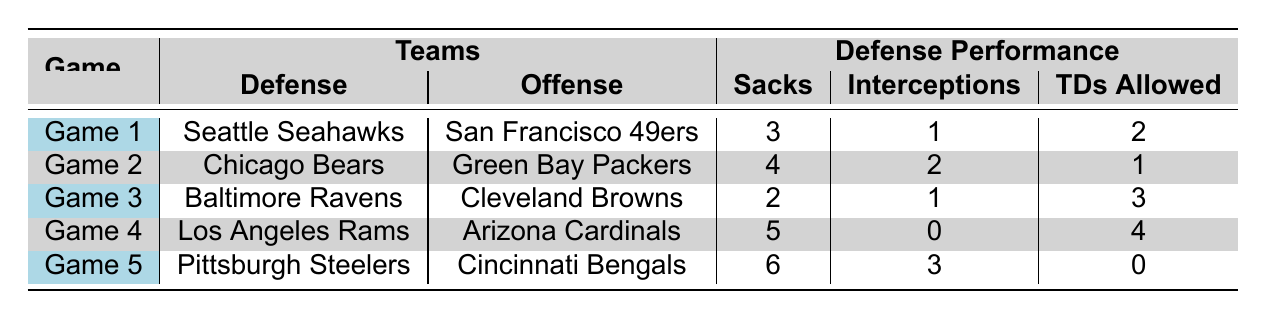What team had the highest number of sacks in a game? The highest number of sacks in a game is 6, which is recorded by the Pittsburgh Steelers in Game 5.
Answer: Pittsburgh Steelers Which defense allowed the least total yards? The total yards allowed by each defense show that the Pittsburgh Steelers allowed only 189 yards in Game 5, which is the least among all games.
Answer: Pittsburgh Steelers Did any defense allow zero touchdowns? In Game 5, the Pittsburgh Steelers allowed zero touchdowns against the Cincinnati Bengals, confirming that at least one defense achieved this feat.
Answer: Yes On which game did the most touchdowns get allowed? The Los Angeles Rams allowed 4 touchdowns in Game 4 against the Arizona Cardinals, which is the highest count of touchdowns allowed in the table.
Answer: Game 4 What is the average number of interceptions in these games? To find the average, sum the interceptions: (1 + 2 + 1 + 0 + 3) = 7. There are 5 games, so average interceptions = 7/5 = 1.4.
Answer: 1.4 Which defense had the best overall performance based on lowest touchdowns allowed and highest sacks? The Pittsburgh Steelers had the highest sacks (6) and allowed the fewest touchdowns (0) against the Bengals in Game 5, presenting it as the best performance.
Answer: Pittsburgh Steelers How many games had a defense that recorded 4 or more sacks? In the table, both Game 2 (4 sacks by Chicago Bears) and Game 5 (6 sacks by Pittsburgh Steelers) show defenses with 4 or more sacks, thus equating to 2 games.
Answer: 2 games Was there any game where a defense recorded more interceptions than sacks? In Game 4, the Los Angeles Rams had 0 interceptions and 5 sacks, showing that there was no game meeting the requirement of more interceptions than sacks.
Answer: No 